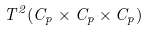Convert formula to latex. <formula><loc_0><loc_0><loc_500><loc_500>T ^ { 2 } ( C _ { p } \times C _ { p } \times C _ { p } )</formula> 